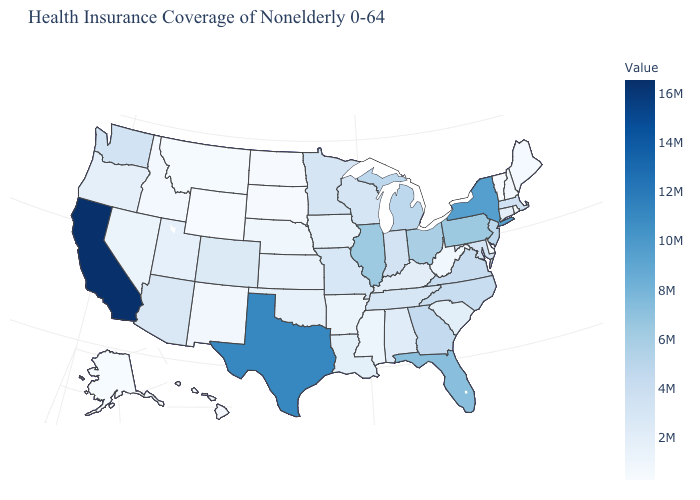Which states have the highest value in the USA?
Be succinct. California. Does New Hampshire have the lowest value in the USA?
Short answer required. No. Does California have the highest value in the USA?
Write a very short answer. Yes. Among the states that border Ohio , does West Virginia have the lowest value?
Short answer required. Yes. Is the legend a continuous bar?
Write a very short answer. Yes. Among the states that border Florida , does Alabama have the lowest value?
Be succinct. Yes. Among the states that border Illinois , does Missouri have the lowest value?
Write a very short answer. No. 